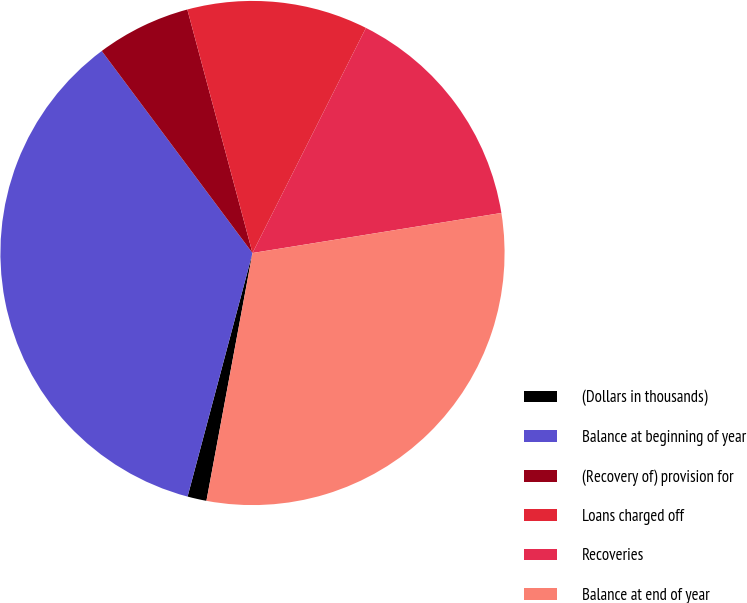Convert chart. <chart><loc_0><loc_0><loc_500><loc_500><pie_chart><fcel>(Dollars in thousands)<fcel>Balance at beginning of year<fcel>(Recovery of) provision for<fcel>Loans charged off<fcel>Recoveries<fcel>Balance at end of year<nl><fcel>1.22%<fcel>35.65%<fcel>6.04%<fcel>11.59%<fcel>15.03%<fcel>30.46%<nl></chart> 